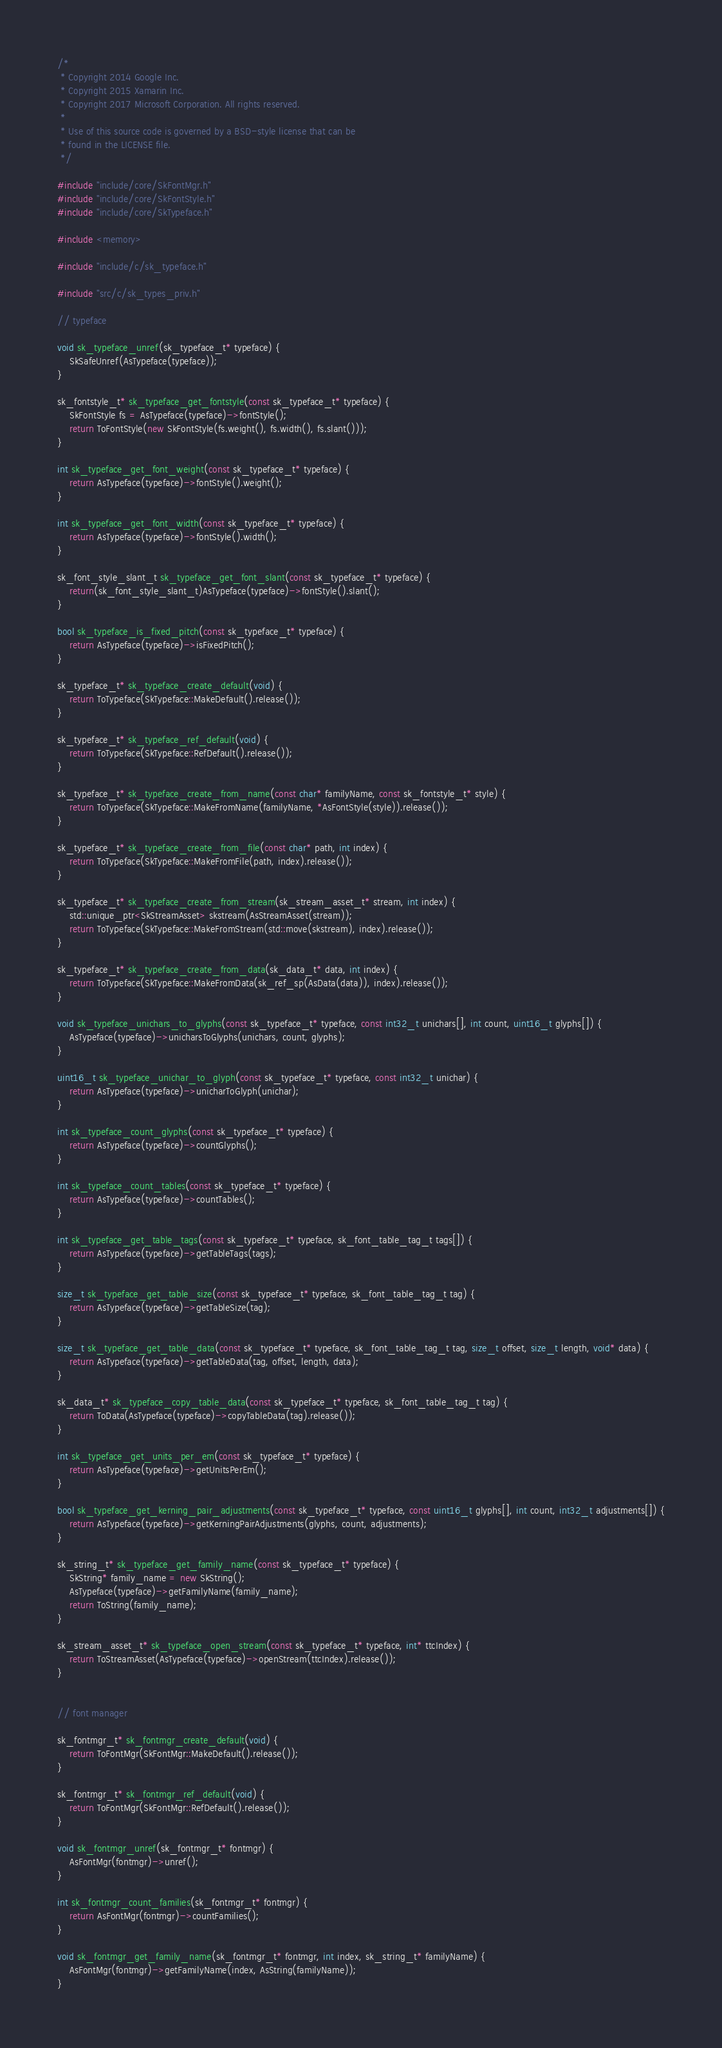Convert code to text. <code><loc_0><loc_0><loc_500><loc_500><_C++_>/*
 * Copyright 2014 Google Inc.
 * Copyright 2015 Xamarin Inc.
 * Copyright 2017 Microsoft Corporation. All rights reserved.
 *
 * Use of this source code is governed by a BSD-style license that can be
 * found in the LICENSE file.
 */

#include "include/core/SkFontMgr.h"
#include "include/core/SkFontStyle.h"
#include "include/core/SkTypeface.h"

#include <memory>

#include "include/c/sk_typeface.h"

#include "src/c/sk_types_priv.h"

// typeface

void sk_typeface_unref(sk_typeface_t* typeface) {
    SkSafeUnref(AsTypeface(typeface));
}

sk_fontstyle_t* sk_typeface_get_fontstyle(const sk_typeface_t* typeface) {
    SkFontStyle fs = AsTypeface(typeface)->fontStyle();
    return ToFontStyle(new SkFontStyle(fs.weight(), fs.width(), fs.slant()));
}

int sk_typeface_get_font_weight(const sk_typeface_t* typeface) {
    return AsTypeface(typeface)->fontStyle().weight();
}

int sk_typeface_get_font_width(const sk_typeface_t* typeface) {
    return AsTypeface(typeface)->fontStyle().width();
}

sk_font_style_slant_t sk_typeface_get_font_slant(const sk_typeface_t* typeface) {
    return(sk_font_style_slant_t)AsTypeface(typeface)->fontStyle().slant();
}

bool sk_typeface_is_fixed_pitch(const sk_typeface_t* typeface) {
    return AsTypeface(typeface)->isFixedPitch();
}

sk_typeface_t* sk_typeface_create_default(void) {
    return ToTypeface(SkTypeface::MakeDefault().release());
}

sk_typeface_t* sk_typeface_ref_default(void) {
    return ToTypeface(SkTypeface::RefDefault().release());
}

sk_typeface_t* sk_typeface_create_from_name(const char* familyName, const sk_fontstyle_t* style) {
    return ToTypeface(SkTypeface::MakeFromName(familyName, *AsFontStyle(style)).release());
}

sk_typeface_t* sk_typeface_create_from_file(const char* path, int index) {
    return ToTypeface(SkTypeface::MakeFromFile(path, index).release());
}

sk_typeface_t* sk_typeface_create_from_stream(sk_stream_asset_t* stream, int index) {
    std::unique_ptr<SkStreamAsset> skstream(AsStreamAsset(stream));
    return ToTypeface(SkTypeface::MakeFromStream(std::move(skstream), index).release());
}

sk_typeface_t* sk_typeface_create_from_data(sk_data_t* data, int index) {
    return ToTypeface(SkTypeface::MakeFromData(sk_ref_sp(AsData(data)), index).release());
}

void sk_typeface_unichars_to_glyphs(const sk_typeface_t* typeface, const int32_t unichars[], int count, uint16_t glyphs[]) {
    AsTypeface(typeface)->unicharsToGlyphs(unichars, count, glyphs);
}

uint16_t sk_typeface_unichar_to_glyph(const sk_typeface_t* typeface, const int32_t unichar) {
    return AsTypeface(typeface)->unicharToGlyph(unichar);
}

int sk_typeface_count_glyphs(const sk_typeface_t* typeface) {
    return AsTypeface(typeface)->countGlyphs();
}

int sk_typeface_count_tables(const sk_typeface_t* typeface) {
    return AsTypeface(typeface)->countTables();
}

int sk_typeface_get_table_tags(const sk_typeface_t* typeface, sk_font_table_tag_t tags[]) {
    return AsTypeface(typeface)->getTableTags(tags);
}

size_t sk_typeface_get_table_size(const sk_typeface_t* typeface, sk_font_table_tag_t tag) {
    return AsTypeface(typeface)->getTableSize(tag);
}

size_t sk_typeface_get_table_data(const sk_typeface_t* typeface, sk_font_table_tag_t tag, size_t offset, size_t length, void* data) {
    return AsTypeface(typeface)->getTableData(tag, offset, length, data);
}

sk_data_t* sk_typeface_copy_table_data(const sk_typeface_t* typeface, sk_font_table_tag_t tag) {
    return ToData(AsTypeface(typeface)->copyTableData(tag).release());
}

int sk_typeface_get_units_per_em(const sk_typeface_t* typeface) {
    return AsTypeface(typeface)->getUnitsPerEm();
}

bool sk_typeface_get_kerning_pair_adjustments(const sk_typeface_t* typeface, const uint16_t glyphs[], int count, int32_t adjustments[]) {
    return AsTypeface(typeface)->getKerningPairAdjustments(glyphs, count, adjustments);
}

sk_string_t* sk_typeface_get_family_name(const sk_typeface_t* typeface) {
    SkString* family_name = new SkString();
    AsTypeface(typeface)->getFamilyName(family_name);
    return ToString(family_name);
}

sk_stream_asset_t* sk_typeface_open_stream(const sk_typeface_t* typeface, int* ttcIndex) {
    return ToStreamAsset(AsTypeface(typeface)->openStream(ttcIndex).release());
}


// font manager

sk_fontmgr_t* sk_fontmgr_create_default(void) {
    return ToFontMgr(SkFontMgr::MakeDefault().release());
}

sk_fontmgr_t* sk_fontmgr_ref_default(void) {
    return ToFontMgr(SkFontMgr::RefDefault().release());
}

void sk_fontmgr_unref(sk_fontmgr_t* fontmgr) {
    AsFontMgr(fontmgr)->unref();
}

int sk_fontmgr_count_families(sk_fontmgr_t* fontmgr) {
    return AsFontMgr(fontmgr)->countFamilies();
}

void sk_fontmgr_get_family_name(sk_fontmgr_t* fontmgr, int index, sk_string_t* familyName) {
    AsFontMgr(fontmgr)->getFamilyName(index, AsString(familyName));
}
</code> 